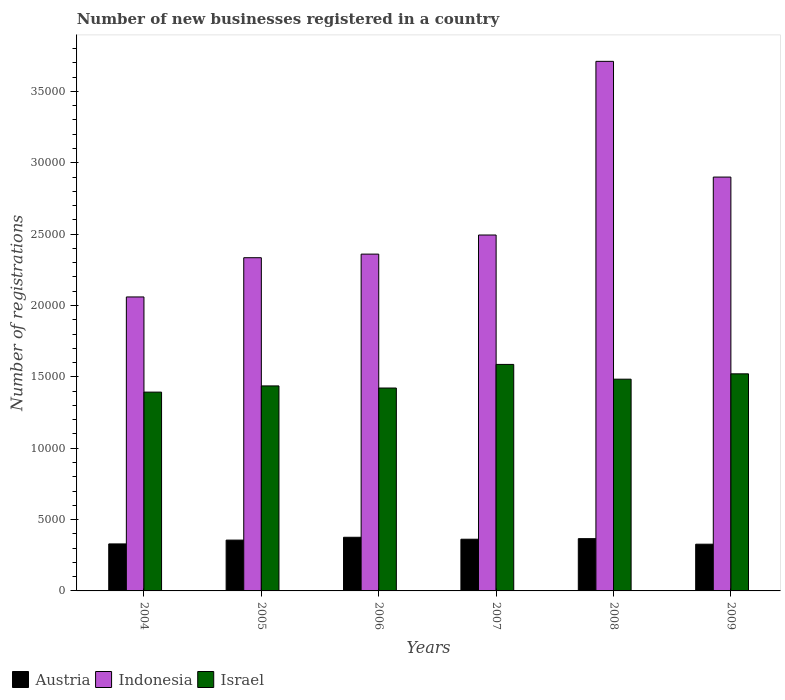How many bars are there on the 4th tick from the left?
Give a very brief answer. 3. What is the label of the 6th group of bars from the left?
Your answer should be compact. 2009. What is the number of new businesses registered in Israel in 2006?
Your response must be concise. 1.42e+04. Across all years, what is the maximum number of new businesses registered in Israel?
Make the answer very short. 1.59e+04. Across all years, what is the minimum number of new businesses registered in Israel?
Ensure brevity in your answer.  1.39e+04. In which year was the number of new businesses registered in Israel maximum?
Provide a short and direct response. 2007. In which year was the number of new businesses registered in Israel minimum?
Your answer should be compact. 2004. What is the total number of new businesses registered in Austria in the graph?
Your response must be concise. 2.12e+04. What is the difference between the number of new businesses registered in Israel in 2004 and that in 2009?
Keep it short and to the point. -1281. What is the difference between the number of new businesses registered in Austria in 2007 and the number of new businesses registered in Israel in 2006?
Provide a short and direct response. -1.06e+04. What is the average number of new businesses registered in Indonesia per year?
Make the answer very short. 2.64e+04. In the year 2004, what is the difference between the number of new businesses registered in Austria and number of new businesses registered in Israel?
Your answer should be compact. -1.06e+04. What is the ratio of the number of new businesses registered in Israel in 2004 to that in 2006?
Offer a very short reply. 0.98. What is the difference between the highest and the second highest number of new businesses registered in Indonesia?
Your answer should be compact. 8108. What is the difference between the highest and the lowest number of new businesses registered in Israel?
Provide a short and direct response. 1941. Is the sum of the number of new businesses registered in Indonesia in 2006 and 2007 greater than the maximum number of new businesses registered in Austria across all years?
Give a very brief answer. Yes. What does the 3rd bar from the left in 2008 represents?
Make the answer very short. Israel. What does the 1st bar from the right in 2006 represents?
Your answer should be compact. Israel. Is it the case that in every year, the sum of the number of new businesses registered in Indonesia and number of new businesses registered in Israel is greater than the number of new businesses registered in Austria?
Offer a terse response. Yes. How many bars are there?
Your response must be concise. 18. Does the graph contain grids?
Give a very brief answer. No. How many legend labels are there?
Offer a very short reply. 3. How are the legend labels stacked?
Offer a very short reply. Horizontal. What is the title of the graph?
Your response must be concise. Number of new businesses registered in a country. What is the label or title of the Y-axis?
Give a very brief answer. Number of registrations. What is the Number of registrations in Austria in 2004?
Offer a very short reply. 3294. What is the Number of registrations of Indonesia in 2004?
Your response must be concise. 2.06e+04. What is the Number of registrations of Israel in 2004?
Your answer should be compact. 1.39e+04. What is the Number of registrations of Austria in 2005?
Provide a succinct answer. 3561. What is the Number of registrations of Indonesia in 2005?
Your answer should be compact. 2.33e+04. What is the Number of registrations of Israel in 2005?
Offer a very short reply. 1.44e+04. What is the Number of registrations in Austria in 2006?
Your answer should be compact. 3759. What is the Number of registrations of Indonesia in 2006?
Your answer should be compact. 2.36e+04. What is the Number of registrations in Israel in 2006?
Provide a short and direct response. 1.42e+04. What is the Number of registrations of Austria in 2007?
Provide a short and direct response. 3622. What is the Number of registrations of Indonesia in 2007?
Offer a terse response. 2.49e+04. What is the Number of registrations of Israel in 2007?
Keep it short and to the point. 1.59e+04. What is the Number of registrations of Austria in 2008?
Keep it short and to the point. 3663. What is the Number of registrations of Indonesia in 2008?
Your response must be concise. 3.71e+04. What is the Number of registrations of Israel in 2008?
Keep it short and to the point. 1.48e+04. What is the Number of registrations of Austria in 2009?
Your response must be concise. 3274. What is the Number of registrations in Indonesia in 2009?
Provide a short and direct response. 2.90e+04. What is the Number of registrations in Israel in 2009?
Offer a terse response. 1.52e+04. Across all years, what is the maximum Number of registrations in Austria?
Give a very brief answer. 3759. Across all years, what is the maximum Number of registrations in Indonesia?
Give a very brief answer. 3.71e+04. Across all years, what is the maximum Number of registrations in Israel?
Offer a very short reply. 1.59e+04. Across all years, what is the minimum Number of registrations of Austria?
Your answer should be compact. 3274. Across all years, what is the minimum Number of registrations of Indonesia?
Offer a terse response. 2.06e+04. Across all years, what is the minimum Number of registrations in Israel?
Ensure brevity in your answer.  1.39e+04. What is the total Number of registrations in Austria in the graph?
Your response must be concise. 2.12e+04. What is the total Number of registrations in Indonesia in the graph?
Make the answer very short. 1.59e+05. What is the total Number of registrations of Israel in the graph?
Offer a terse response. 8.84e+04. What is the difference between the Number of registrations in Austria in 2004 and that in 2005?
Provide a short and direct response. -267. What is the difference between the Number of registrations of Indonesia in 2004 and that in 2005?
Keep it short and to the point. -2750. What is the difference between the Number of registrations in Israel in 2004 and that in 2005?
Offer a very short reply. -434. What is the difference between the Number of registrations of Austria in 2004 and that in 2006?
Give a very brief answer. -465. What is the difference between the Number of registrations of Indonesia in 2004 and that in 2006?
Provide a succinct answer. -3001. What is the difference between the Number of registrations in Israel in 2004 and that in 2006?
Give a very brief answer. -287. What is the difference between the Number of registrations in Austria in 2004 and that in 2007?
Ensure brevity in your answer.  -328. What is the difference between the Number of registrations in Indonesia in 2004 and that in 2007?
Keep it short and to the point. -4340. What is the difference between the Number of registrations of Israel in 2004 and that in 2007?
Keep it short and to the point. -1941. What is the difference between the Number of registrations of Austria in 2004 and that in 2008?
Offer a terse response. -369. What is the difference between the Number of registrations in Indonesia in 2004 and that in 2008?
Your answer should be compact. -1.65e+04. What is the difference between the Number of registrations of Israel in 2004 and that in 2008?
Offer a very short reply. -906. What is the difference between the Number of registrations in Austria in 2004 and that in 2009?
Provide a succinct answer. 20. What is the difference between the Number of registrations in Indonesia in 2004 and that in 2009?
Your response must be concise. -8400. What is the difference between the Number of registrations in Israel in 2004 and that in 2009?
Make the answer very short. -1281. What is the difference between the Number of registrations of Austria in 2005 and that in 2006?
Your answer should be very brief. -198. What is the difference between the Number of registrations of Indonesia in 2005 and that in 2006?
Keep it short and to the point. -251. What is the difference between the Number of registrations in Israel in 2005 and that in 2006?
Your answer should be very brief. 147. What is the difference between the Number of registrations in Austria in 2005 and that in 2007?
Offer a very short reply. -61. What is the difference between the Number of registrations of Indonesia in 2005 and that in 2007?
Provide a short and direct response. -1590. What is the difference between the Number of registrations of Israel in 2005 and that in 2007?
Offer a very short reply. -1507. What is the difference between the Number of registrations of Austria in 2005 and that in 2008?
Offer a terse response. -102. What is the difference between the Number of registrations in Indonesia in 2005 and that in 2008?
Your response must be concise. -1.38e+04. What is the difference between the Number of registrations in Israel in 2005 and that in 2008?
Your response must be concise. -472. What is the difference between the Number of registrations of Austria in 2005 and that in 2009?
Give a very brief answer. 287. What is the difference between the Number of registrations of Indonesia in 2005 and that in 2009?
Make the answer very short. -5650. What is the difference between the Number of registrations in Israel in 2005 and that in 2009?
Keep it short and to the point. -847. What is the difference between the Number of registrations in Austria in 2006 and that in 2007?
Keep it short and to the point. 137. What is the difference between the Number of registrations in Indonesia in 2006 and that in 2007?
Your answer should be very brief. -1339. What is the difference between the Number of registrations of Israel in 2006 and that in 2007?
Give a very brief answer. -1654. What is the difference between the Number of registrations in Austria in 2006 and that in 2008?
Offer a terse response. 96. What is the difference between the Number of registrations in Indonesia in 2006 and that in 2008?
Your answer should be compact. -1.35e+04. What is the difference between the Number of registrations of Israel in 2006 and that in 2008?
Keep it short and to the point. -619. What is the difference between the Number of registrations in Austria in 2006 and that in 2009?
Provide a short and direct response. 485. What is the difference between the Number of registrations of Indonesia in 2006 and that in 2009?
Give a very brief answer. -5399. What is the difference between the Number of registrations in Israel in 2006 and that in 2009?
Your response must be concise. -994. What is the difference between the Number of registrations in Austria in 2007 and that in 2008?
Ensure brevity in your answer.  -41. What is the difference between the Number of registrations of Indonesia in 2007 and that in 2008?
Provide a short and direct response. -1.22e+04. What is the difference between the Number of registrations of Israel in 2007 and that in 2008?
Your answer should be very brief. 1035. What is the difference between the Number of registrations in Austria in 2007 and that in 2009?
Your answer should be very brief. 348. What is the difference between the Number of registrations of Indonesia in 2007 and that in 2009?
Provide a short and direct response. -4060. What is the difference between the Number of registrations of Israel in 2007 and that in 2009?
Ensure brevity in your answer.  660. What is the difference between the Number of registrations in Austria in 2008 and that in 2009?
Provide a short and direct response. 389. What is the difference between the Number of registrations of Indonesia in 2008 and that in 2009?
Provide a succinct answer. 8108. What is the difference between the Number of registrations in Israel in 2008 and that in 2009?
Your answer should be compact. -375. What is the difference between the Number of registrations in Austria in 2004 and the Number of registrations in Indonesia in 2005?
Make the answer very short. -2.01e+04. What is the difference between the Number of registrations in Austria in 2004 and the Number of registrations in Israel in 2005?
Provide a short and direct response. -1.11e+04. What is the difference between the Number of registrations in Indonesia in 2004 and the Number of registrations in Israel in 2005?
Your response must be concise. 6234. What is the difference between the Number of registrations of Austria in 2004 and the Number of registrations of Indonesia in 2006?
Give a very brief answer. -2.03e+04. What is the difference between the Number of registrations in Austria in 2004 and the Number of registrations in Israel in 2006?
Provide a succinct answer. -1.09e+04. What is the difference between the Number of registrations of Indonesia in 2004 and the Number of registrations of Israel in 2006?
Keep it short and to the point. 6381. What is the difference between the Number of registrations of Austria in 2004 and the Number of registrations of Indonesia in 2007?
Your answer should be compact. -2.16e+04. What is the difference between the Number of registrations in Austria in 2004 and the Number of registrations in Israel in 2007?
Make the answer very short. -1.26e+04. What is the difference between the Number of registrations in Indonesia in 2004 and the Number of registrations in Israel in 2007?
Keep it short and to the point. 4727. What is the difference between the Number of registrations of Austria in 2004 and the Number of registrations of Indonesia in 2008?
Offer a very short reply. -3.38e+04. What is the difference between the Number of registrations of Austria in 2004 and the Number of registrations of Israel in 2008?
Ensure brevity in your answer.  -1.15e+04. What is the difference between the Number of registrations of Indonesia in 2004 and the Number of registrations of Israel in 2008?
Your answer should be compact. 5762. What is the difference between the Number of registrations in Austria in 2004 and the Number of registrations in Indonesia in 2009?
Keep it short and to the point. -2.57e+04. What is the difference between the Number of registrations of Austria in 2004 and the Number of registrations of Israel in 2009?
Give a very brief answer. -1.19e+04. What is the difference between the Number of registrations in Indonesia in 2004 and the Number of registrations in Israel in 2009?
Your answer should be very brief. 5387. What is the difference between the Number of registrations in Austria in 2005 and the Number of registrations in Indonesia in 2006?
Your response must be concise. -2.00e+04. What is the difference between the Number of registrations of Austria in 2005 and the Number of registrations of Israel in 2006?
Keep it short and to the point. -1.07e+04. What is the difference between the Number of registrations of Indonesia in 2005 and the Number of registrations of Israel in 2006?
Provide a succinct answer. 9131. What is the difference between the Number of registrations of Austria in 2005 and the Number of registrations of Indonesia in 2007?
Give a very brief answer. -2.14e+04. What is the difference between the Number of registrations of Austria in 2005 and the Number of registrations of Israel in 2007?
Your answer should be compact. -1.23e+04. What is the difference between the Number of registrations in Indonesia in 2005 and the Number of registrations in Israel in 2007?
Offer a terse response. 7477. What is the difference between the Number of registrations of Austria in 2005 and the Number of registrations of Indonesia in 2008?
Offer a terse response. -3.35e+04. What is the difference between the Number of registrations of Austria in 2005 and the Number of registrations of Israel in 2008?
Ensure brevity in your answer.  -1.13e+04. What is the difference between the Number of registrations of Indonesia in 2005 and the Number of registrations of Israel in 2008?
Keep it short and to the point. 8512. What is the difference between the Number of registrations of Austria in 2005 and the Number of registrations of Indonesia in 2009?
Keep it short and to the point. -2.54e+04. What is the difference between the Number of registrations of Austria in 2005 and the Number of registrations of Israel in 2009?
Keep it short and to the point. -1.16e+04. What is the difference between the Number of registrations of Indonesia in 2005 and the Number of registrations of Israel in 2009?
Provide a short and direct response. 8137. What is the difference between the Number of registrations in Austria in 2006 and the Number of registrations in Indonesia in 2007?
Make the answer very short. -2.12e+04. What is the difference between the Number of registrations in Austria in 2006 and the Number of registrations in Israel in 2007?
Keep it short and to the point. -1.21e+04. What is the difference between the Number of registrations of Indonesia in 2006 and the Number of registrations of Israel in 2007?
Ensure brevity in your answer.  7728. What is the difference between the Number of registrations of Austria in 2006 and the Number of registrations of Indonesia in 2008?
Your answer should be very brief. -3.33e+04. What is the difference between the Number of registrations in Austria in 2006 and the Number of registrations in Israel in 2008?
Keep it short and to the point. -1.11e+04. What is the difference between the Number of registrations in Indonesia in 2006 and the Number of registrations in Israel in 2008?
Offer a terse response. 8763. What is the difference between the Number of registrations in Austria in 2006 and the Number of registrations in Indonesia in 2009?
Give a very brief answer. -2.52e+04. What is the difference between the Number of registrations in Austria in 2006 and the Number of registrations in Israel in 2009?
Make the answer very short. -1.15e+04. What is the difference between the Number of registrations in Indonesia in 2006 and the Number of registrations in Israel in 2009?
Provide a short and direct response. 8388. What is the difference between the Number of registrations in Austria in 2007 and the Number of registrations in Indonesia in 2008?
Provide a short and direct response. -3.35e+04. What is the difference between the Number of registrations in Austria in 2007 and the Number of registrations in Israel in 2008?
Provide a succinct answer. -1.12e+04. What is the difference between the Number of registrations in Indonesia in 2007 and the Number of registrations in Israel in 2008?
Provide a short and direct response. 1.01e+04. What is the difference between the Number of registrations of Austria in 2007 and the Number of registrations of Indonesia in 2009?
Make the answer very short. -2.54e+04. What is the difference between the Number of registrations of Austria in 2007 and the Number of registrations of Israel in 2009?
Give a very brief answer. -1.16e+04. What is the difference between the Number of registrations of Indonesia in 2007 and the Number of registrations of Israel in 2009?
Ensure brevity in your answer.  9727. What is the difference between the Number of registrations of Austria in 2008 and the Number of registrations of Indonesia in 2009?
Your answer should be compact. -2.53e+04. What is the difference between the Number of registrations of Austria in 2008 and the Number of registrations of Israel in 2009?
Give a very brief answer. -1.15e+04. What is the difference between the Number of registrations in Indonesia in 2008 and the Number of registrations in Israel in 2009?
Your answer should be very brief. 2.19e+04. What is the average Number of registrations of Austria per year?
Ensure brevity in your answer.  3528.83. What is the average Number of registrations in Indonesia per year?
Your response must be concise. 2.64e+04. What is the average Number of registrations of Israel per year?
Offer a terse response. 1.47e+04. In the year 2004, what is the difference between the Number of registrations in Austria and Number of registrations in Indonesia?
Give a very brief answer. -1.73e+04. In the year 2004, what is the difference between the Number of registrations of Austria and Number of registrations of Israel?
Keep it short and to the point. -1.06e+04. In the year 2004, what is the difference between the Number of registrations of Indonesia and Number of registrations of Israel?
Offer a very short reply. 6668. In the year 2005, what is the difference between the Number of registrations of Austria and Number of registrations of Indonesia?
Ensure brevity in your answer.  -1.98e+04. In the year 2005, what is the difference between the Number of registrations in Austria and Number of registrations in Israel?
Your answer should be very brief. -1.08e+04. In the year 2005, what is the difference between the Number of registrations of Indonesia and Number of registrations of Israel?
Your response must be concise. 8984. In the year 2006, what is the difference between the Number of registrations of Austria and Number of registrations of Indonesia?
Your answer should be very brief. -1.98e+04. In the year 2006, what is the difference between the Number of registrations of Austria and Number of registrations of Israel?
Your answer should be very brief. -1.05e+04. In the year 2006, what is the difference between the Number of registrations of Indonesia and Number of registrations of Israel?
Your answer should be very brief. 9382. In the year 2007, what is the difference between the Number of registrations in Austria and Number of registrations in Indonesia?
Give a very brief answer. -2.13e+04. In the year 2007, what is the difference between the Number of registrations in Austria and Number of registrations in Israel?
Give a very brief answer. -1.22e+04. In the year 2007, what is the difference between the Number of registrations of Indonesia and Number of registrations of Israel?
Your answer should be very brief. 9067. In the year 2008, what is the difference between the Number of registrations of Austria and Number of registrations of Indonesia?
Keep it short and to the point. -3.34e+04. In the year 2008, what is the difference between the Number of registrations in Austria and Number of registrations in Israel?
Keep it short and to the point. -1.12e+04. In the year 2008, what is the difference between the Number of registrations in Indonesia and Number of registrations in Israel?
Make the answer very short. 2.23e+04. In the year 2009, what is the difference between the Number of registrations of Austria and Number of registrations of Indonesia?
Give a very brief answer. -2.57e+04. In the year 2009, what is the difference between the Number of registrations of Austria and Number of registrations of Israel?
Provide a short and direct response. -1.19e+04. In the year 2009, what is the difference between the Number of registrations in Indonesia and Number of registrations in Israel?
Keep it short and to the point. 1.38e+04. What is the ratio of the Number of registrations in Austria in 2004 to that in 2005?
Keep it short and to the point. 0.93. What is the ratio of the Number of registrations of Indonesia in 2004 to that in 2005?
Give a very brief answer. 0.88. What is the ratio of the Number of registrations of Israel in 2004 to that in 2005?
Offer a very short reply. 0.97. What is the ratio of the Number of registrations of Austria in 2004 to that in 2006?
Ensure brevity in your answer.  0.88. What is the ratio of the Number of registrations in Indonesia in 2004 to that in 2006?
Offer a terse response. 0.87. What is the ratio of the Number of registrations in Israel in 2004 to that in 2006?
Ensure brevity in your answer.  0.98. What is the ratio of the Number of registrations of Austria in 2004 to that in 2007?
Make the answer very short. 0.91. What is the ratio of the Number of registrations in Indonesia in 2004 to that in 2007?
Ensure brevity in your answer.  0.83. What is the ratio of the Number of registrations in Israel in 2004 to that in 2007?
Your answer should be very brief. 0.88. What is the ratio of the Number of registrations of Austria in 2004 to that in 2008?
Make the answer very short. 0.9. What is the ratio of the Number of registrations of Indonesia in 2004 to that in 2008?
Give a very brief answer. 0.56. What is the ratio of the Number of registrations in Israel in 2004 to that in 2008?
Make the answer very short. 0.94. What is the ratio of the Number of registrations of Indonesia in 2004 to that in 2009?
Keep it short and to the point. 0.71. What is the ratio of the Number of registrations in Israel in 2004 to that in 2009?
Give a very brief answer. 0.92. What is the ratio of the Number of registrations of Austria in 2005 to that in 2006?
Your response must be concise. 0.95. What is the ratio of the Number of registrations of Indonesia in 2005 to that in 2006?
Ensure brevity in your answer.  0.99. What is the ratio of the Number of registrations in Israel in 2005 to that in 2006?
Make the answer very short. 1.01. What is the ratio of the Number of registrations in Austria in 2005 to that in 2007?
Offer a terse response. 0.98. What is the ratio of the Number of registrations in Indonesia in 2005 to that in 2007?
Offer a very short reply. 0.94. What is the ratio of the Number of registrations of Israel in 2005 to that in 2007?
Your answer should be very brief. 0.91. What is the ratio of the Number of registrations in Austria in 2005 to that in 2008?
Give a very brief answer. 0.97. What is the ratio of the Number of registrations of Indonesia in 2005 to that in 2008?
Provide a succinct answer. 0.63. What is the ratio of the Number of registrations in Israel in 2005 to that in 2008?
Provide a succinct answer. 0.97. What is the ratio of the Number of registrations in Austria in 2005 to that in 2009?
Offer a terse response. 1.09. What is the ratio of the Number of registrations in Indonesia in 2005 to that in 2009?
Provide a short and direct response. 0.81. What is the ratio of the Number of registrations of Israel in 2005 to that in 2009?
Your answer should be very brief. 0.94. What is the ratio of the Number of registrations of Austria in 2006 to that in 2007?
Your answer should be very brief. 1.04. What is the ratio of the Number of registrations of Indonesia in 2006 to that in 2007?
Keep it short and to the point. 0.95. What is the ratio of the Number of registrations in Israel in 2006 to that in 2007?
Give a very brief answer. 0.9. What is the ratio of the Number of registrations of Austria in 2006 to that in 2008?
Your response must be concise. 1.03. What is the ratio of the Number of registrations in Indonesia in 2006 to that in 2008?
Keep it short and to the point. 0.64. What is the ratio of the Number of registrations of Israel in 2006 to that in 2008?
Keep it short and to the point. 0.96. What is the ratio of the Number of registrations in Austria in 2006 to that in 2009?
Offer a very short reply. 1.15. What is the ratio of the Number of registrations of Indonesia in 2006 to that in 2009?
Keep it short and to the point. 0.81. What is the ratio of the Number of registrations in Israel in 2006 to that in 2009?
Keep it short and to the point. 0.93. What is the ratio of the Number of registrations in Indonesia in 2007 to that in 2008?
Offer a terse response. 0.67. What is the ratio of the Number of registrations in Israel in 2007 to that in 2008?
Your answer should be compact. 1.07. What is the ratio of the Number of registrations in Austria in 2007 to that in 2009?
Provide a succinct answer. 1.11. What is the ratio of the Number of registrations of Indonesia in 2007 to that in 2009?
Give a very brief answer. 0.86. What is the ratio of the Number of registrations in Israel in 2007 to that in 2009?
Your answer should be very brief. 1.04. What is the ratio of the Number of registrations in Austria in 2008 to that in 2009?
Keep it short and to the point. 1.12. What is the ratio of the Number of registrations of Indonesia in 2008 to that in 2009?
Your answer should be compact. 1.28. What is the ratio of the Number of registrations in Israel in 2008 to that in 2009?
Provide a short and direct response. 0.98. What is the difference between the highest and the second highest Number of registrations of Austria?
Keep it short and to the point. 96. What is the difference between the highest and the second highest Number of registrations of Indonesia?
Your answer should be compact. 8108. What is the difference between the highest and the second highest Number of registrations of Israel?
Keep it short and to the point. 660. What is the difference between the highest and the lowest Number of registrations of Austria?
Make the answer very short. 485. What is the difference between the highest and the lowest Number of registrations in Indonesia?
Make the answer very short. 1.65e+04. What is the difference between the highest and the lowest Number of registrations in Israel?
Offer a terse response. 1941. 